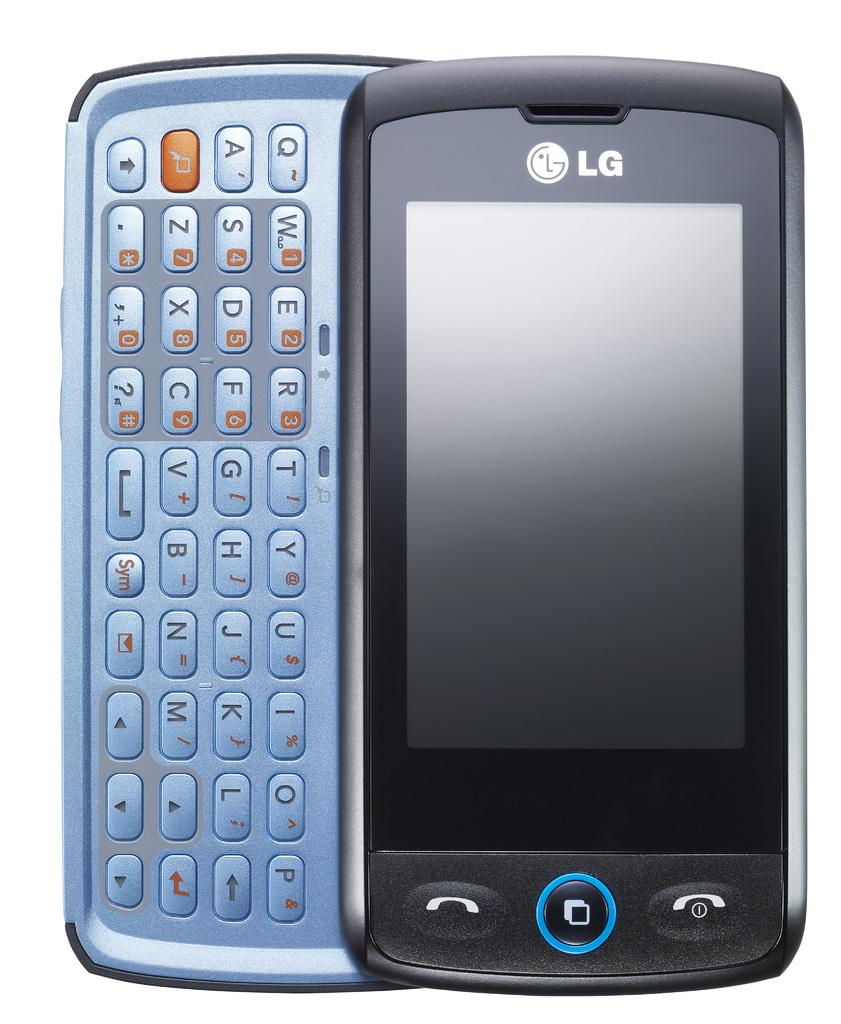<image>
Render a clear and concise summary of the photo. An LG phone has a black face and a blue keyboard. 